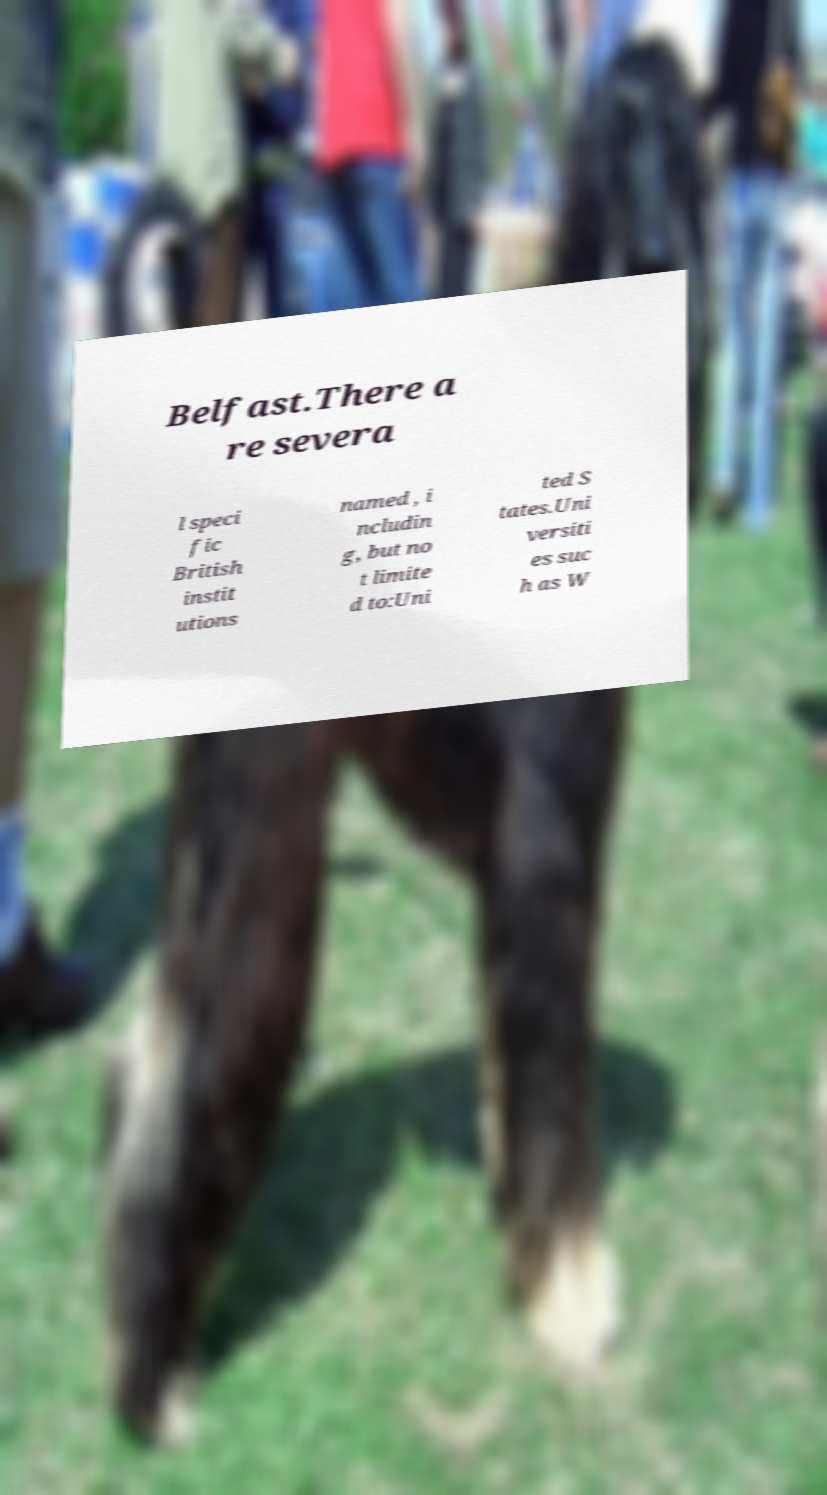Please identify and transcribe the text found in this image. Belfast.There a re severa l speci fic British instit utions named , i ncludin g, but no t limite d to:Uni ted S tates.Uni versiti es suc h as W 